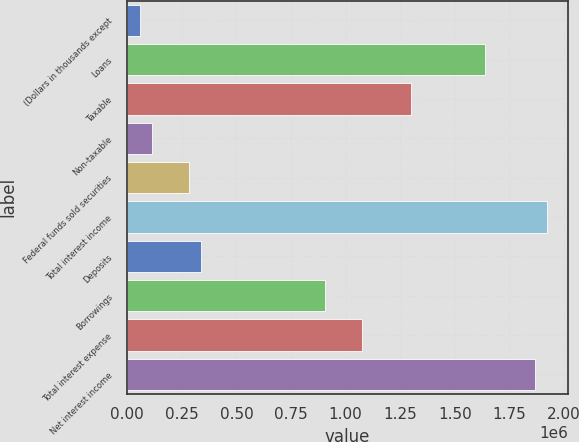Convert chart to OTSL. <chart><loc_0><loc_0><loc_500><loc_500><bar_chart><fcel>(Dollars in thousands except<fcel>Loans<fcel>Taxable<fcel>Non-taxable<fcel>Federal funds sold securities<fcel>Total interest income<fcel>Deposits<fcel>Borrowings<fcel>Total interest expense<fcel>Net interest income<nl><fcel>56542.3<fcel>1.63962e+06<fcel>1.30039e+06<fcel>113081<fcel>282696<fcel>1.92231e+06<fcel>339234<fcel>904618<fcel>1.07423e+06<fcel>1.86577e+06<nl></chart> 